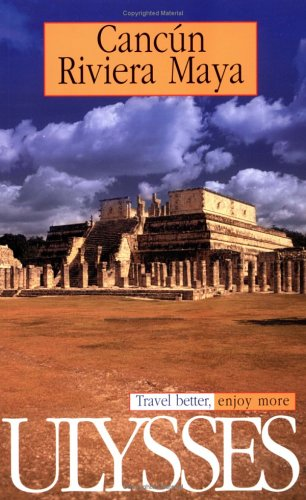What is the title of this book? The title of the book is 'Ulysses Travel Guide Cancun, Riviera Maya (Ulysses Travel Guides)'. It's a guide that potentially offers in-depth travel tips and destination highlights for Cancun and the Riviera Maya. 